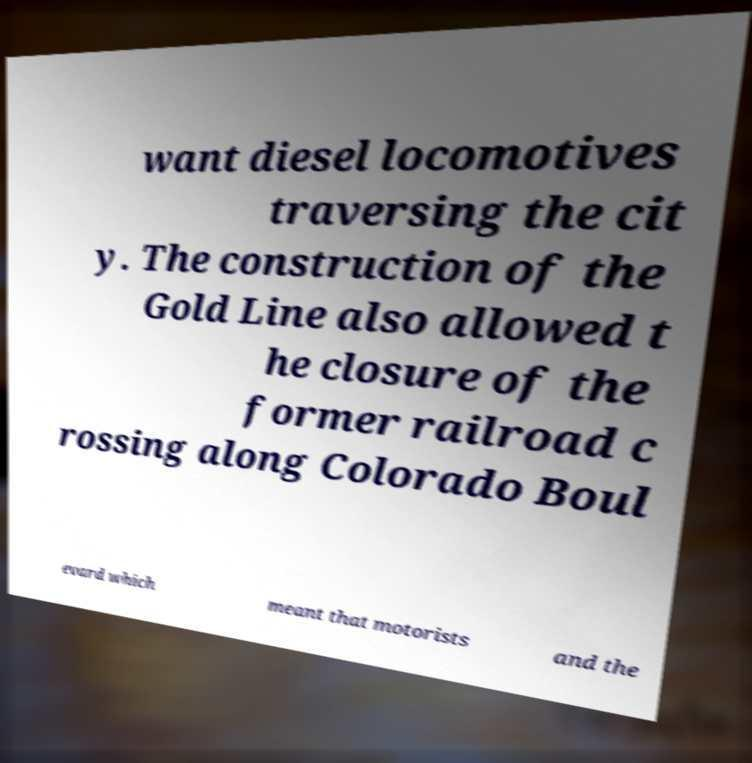Can you read and provide the text displayed in the image?This photo seems to have some interesting text. Can you extract and type it out for me? want diesel locomotives traversing the cit y. The construction of the Gold Line also allowed t he closure of the former railroad c rossing along Colorado Boul evard which meant that motorists and the 